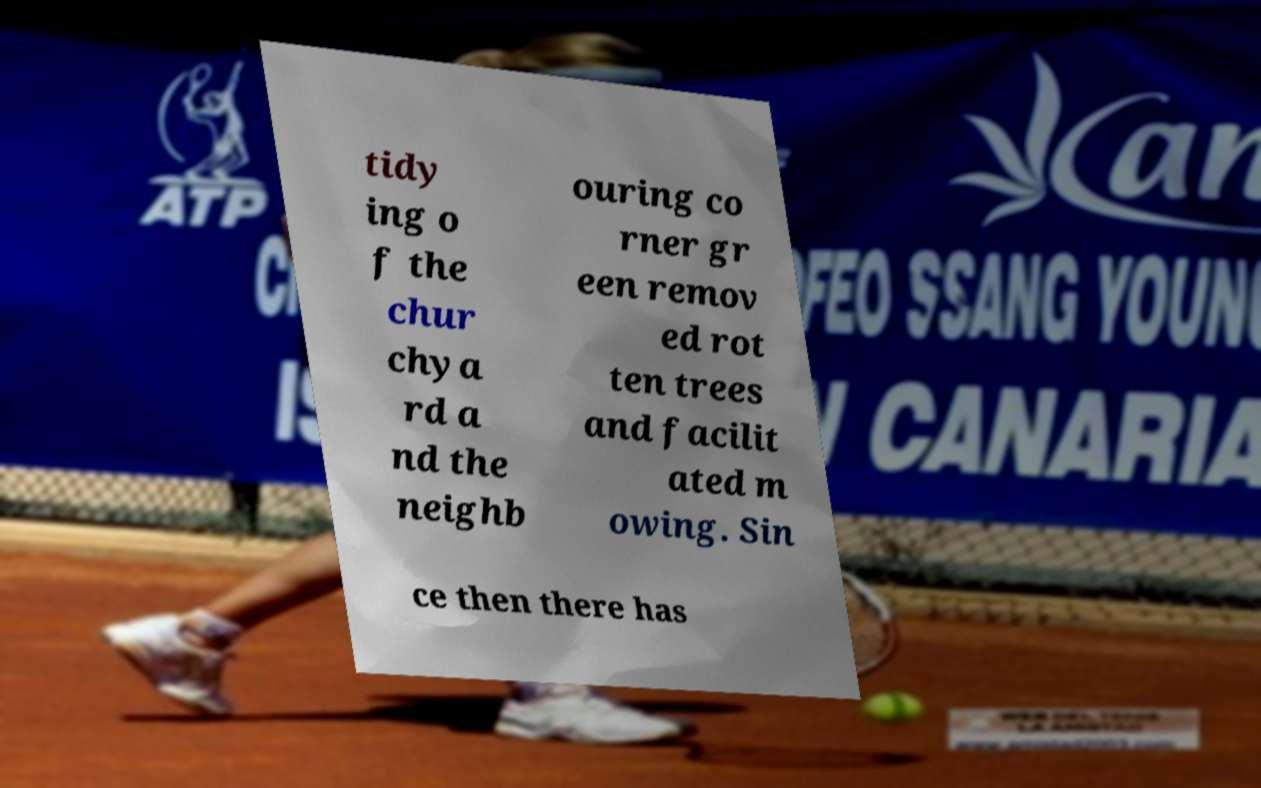Could you assist in decoding the text presented in this image and type it out clearly? tidy ing o f the chur chya rd a nd the neighb ouring co rner gr een remov ed rot ten trees and facilit ated m owing. Sin ce then there has 